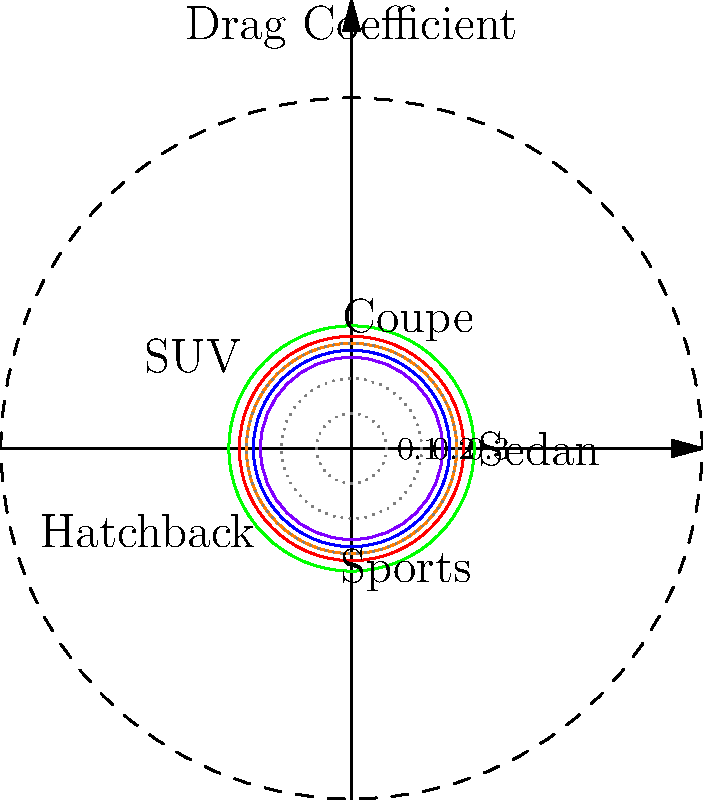The polar chart shows the aerodynamic drag coefficients for various Elite Motor Company car designs. Which model has the lowest drag coefficient, and what is its approximate value? To determine the model with the lowest drag coefficient and its approximate value, we need to follow these steps:

1. Understand the chart:
   - The distance from the center represents the drag coefficient.
   - Each spoke represents a different car model.
   - The concentric circles represent drag coefficient values (0.1, 0.2, 0.3).

2. Identify all models and their approximate drag coefficients:
   - Sedan: $\approx 0.32$
   - Coupe: $\approx 0.28$
   - SUV: $\approx 0.35$
   - Hatchback: $\approx 0.30$
   - Sports: $\approx 0.26$

3. Compare the values:
   The Sports model has the shortest spoke, indicating the lowest drag coefficient.

4. Estimate the value:
   The Sports model's spoke ends between the 0.2 and 0.3 circles, closer to 0.3.
   Its approximate value is 0.26.

Therefore, the Sports model has the lowest drag coefficient, with an approximate value of 0.26.
Answer: Sports model, $\approx 0.26$ 